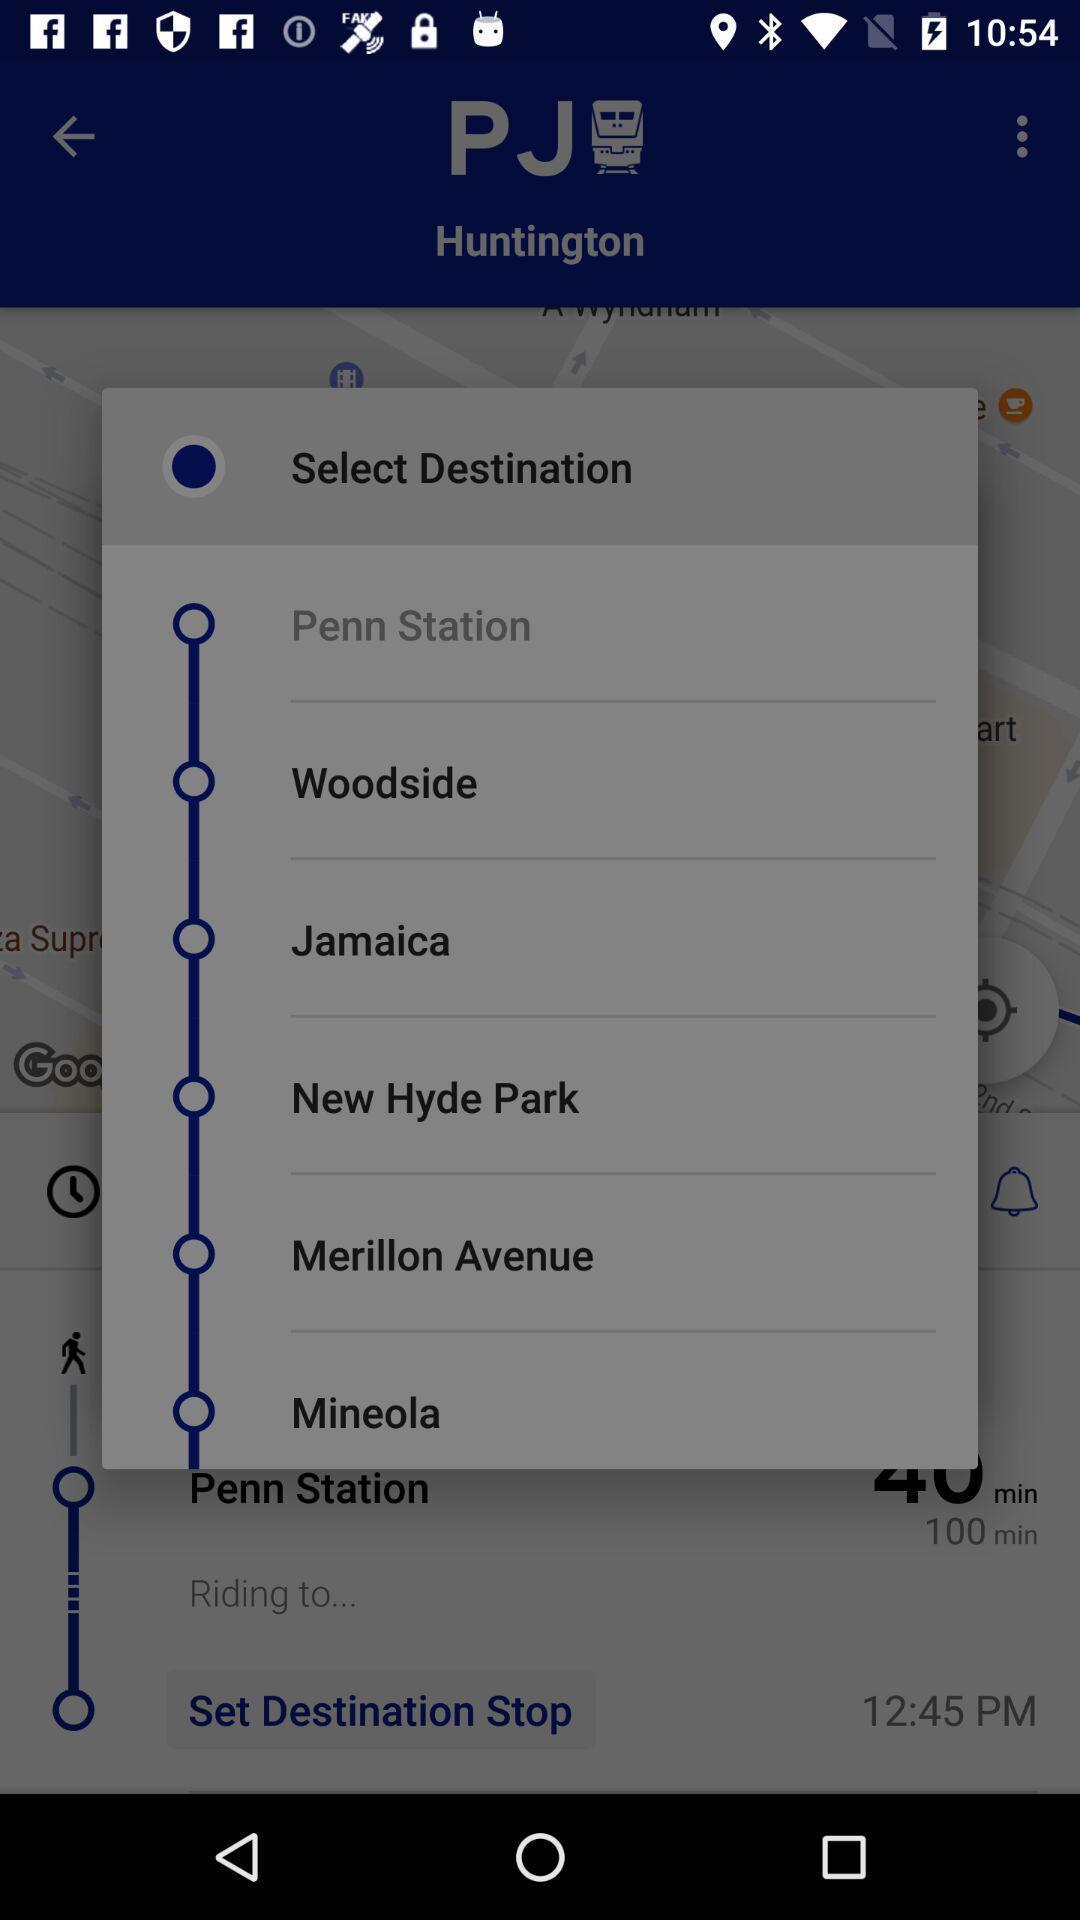Tell me what you see in this picture. Pop-up displaying with different locations to set the destination. 